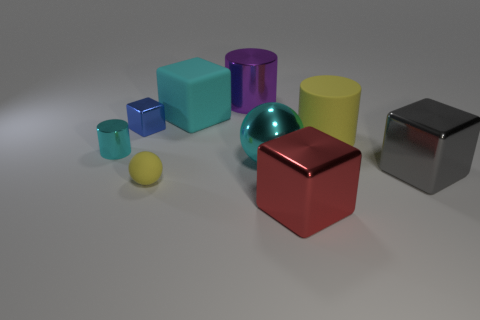Subtract 1 cubes. How many cubes are left? 3 Add 1 big cylinders. How many objects exist? 10 Subtract all spheres. How many objects are left? 7 Add 4 cyan rubber things. How many cyan rubber things exist? 5 Subtract 0 blue spheres. How many objects are left? 9 Subtract all large purple metal things. Subtract all purple metal things. How many objects are left? 7 Add 6 small blue metallic objects. How many small blue metallic objects are left? 7 